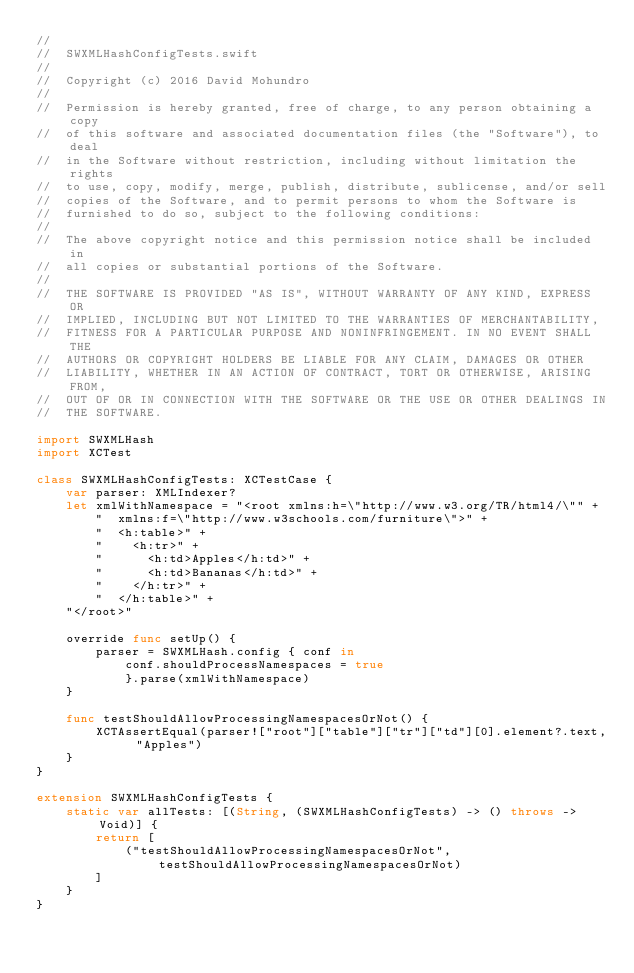Convert code to text. <code><loc_0><loc_0><loc_500><loc_500><_Swift_>//
//  SWXMLHashConfigTests.swift
//
//  Copyright (c) 2016 David Mohundro
//
//  Permission is hereby granted, free of charge, to any person obtaining a copy
//  of this software and associated documentation files (the "Software"), to deal
//  in the Software without restriction, including without limitation the rights
//  to use, copy, modify, merge, publish, distribute, sublicense, and/or sell
//  copies of the Software, and to permit persons to whom the Software is
//  furnished to do so, subject to the following conditions:
//
//  The above copyright notice and this permission notice shall be included in
//  all copies or substantial portions of the Software.
//
//  THE SOFTWARE IS PROVIDED "AS IS", WITHOUT WARRANTY OF ANY KIND, EXPRESS OR
//  IMPLIED, INCLUDING BUT NOT LIMITED TO THE WARRANTIES OF MERCHANTABILITY,
//  FITNESS FOR A PARTICULAR PURPOSE AND NONINFRINGEMENT. IN NO EVENT SHALL THE
//  AUTHORS OR COPYRIGHT HOLDERS BE LIABLE FOR ANY CLAIM, DAMAGES OR OTHER
//  LIABILITY, WHETHER IN AN ACTION OF CONTRACT, TORT OR OTHERWISE, ARISING FROM,
//  OUT OF OR IN CONNECTION WITH THE SOFTWARE OR THE USE OR OTHER DEALINGS IN
//  THE SOFTWARE.

import SWXMLHash
import XCTest

class SWXMLHashConfigTests: XCTestCase {
    var parser: XMLIndexer?
    let xmlWithNamespace = "<root xmlns:h=\"http://www.w3.org/TR/html4/\"" +
        "  xmlns:f=\"http://www.w3schools.com/furniture\">" +
        "  <h:table>" +
        "    <h:tr>" +
        "      <h:td>Apples</h:td>" +
        "      <h:td>Bananas</h:td>" +
        "    </h:tr>" +
        "  </h:table>" +
    "</root>"

    override func setUp() {
        parser = SWXMLHash.config { conf in
            conf.shouldProcessNamespaces = true
            }.parse(xmlWithNamespace)
    }

    func testShouldAllowProcessingNamespacesOrNot() {
        XCTAssertEqual(parser!["root"]["table"]["tr"]["td"][0].element?.text, "Apples")
    }
}

extension SWXMLHashConfigTests {
    static var allTests: [(String, (SWXMLHashConfigTests) -> () throws -> Void)] {
        return [
            ("testShouldAllowProcessingNamespacesOrNot", testShouldAllowProcessingNamespacesOrNot)
        ]
    }
}
</code> 